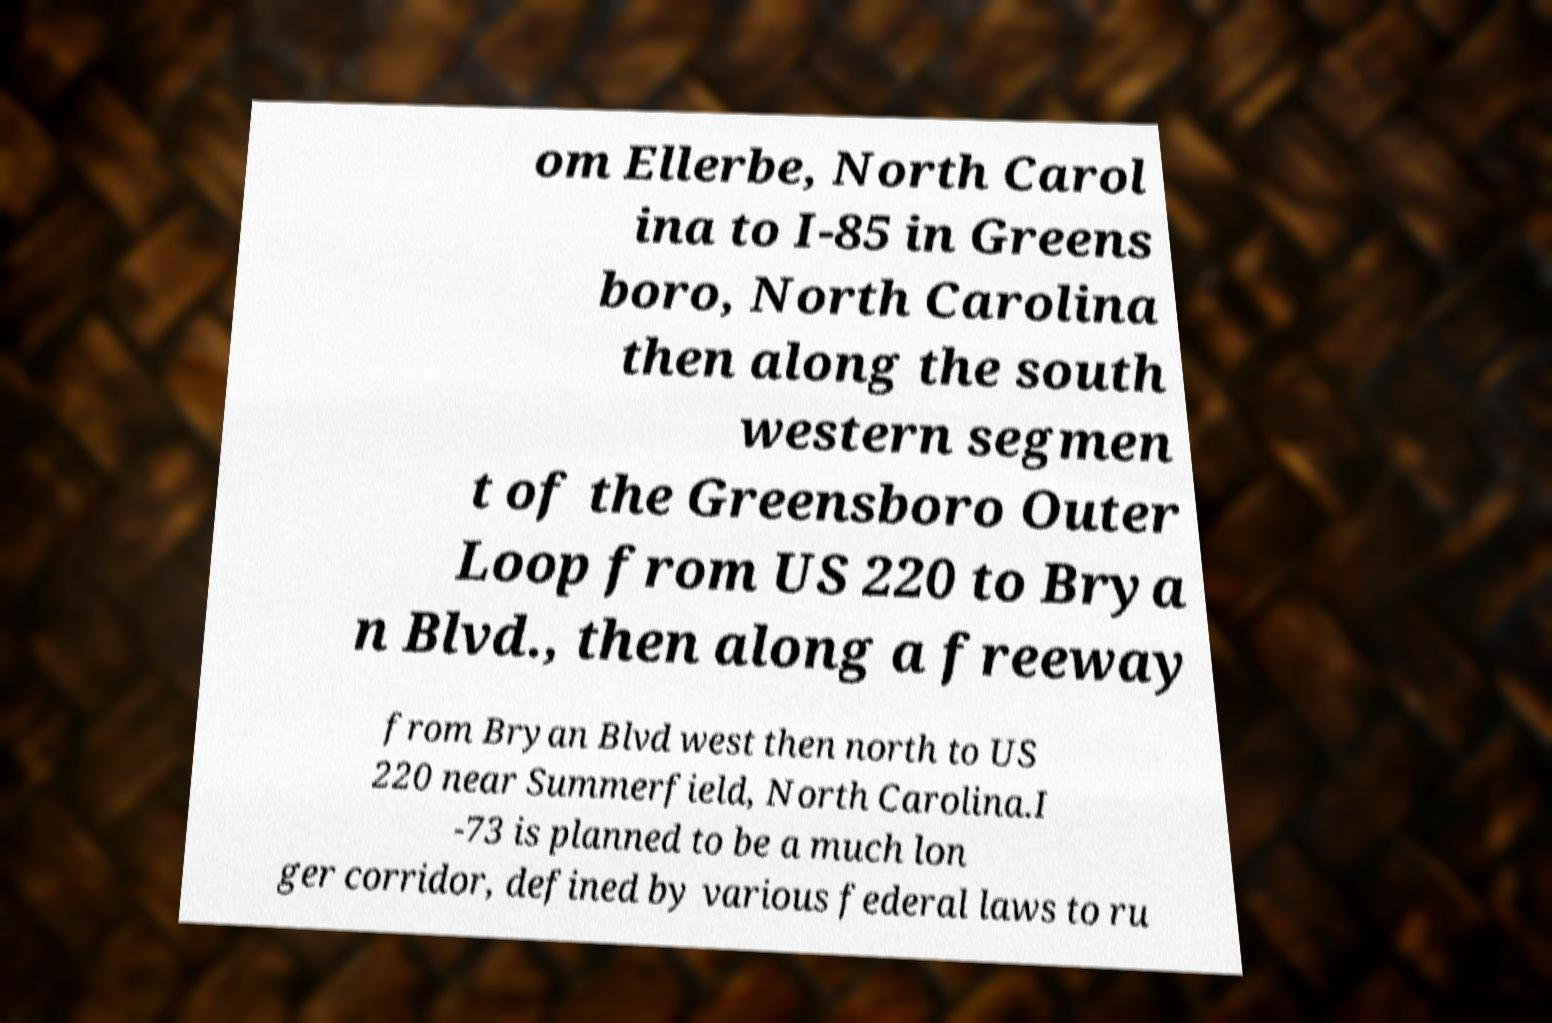Can you read and provide the text displayed in the image?This photo seems to have some interesting text. Can you extract and type it out for me? om Ellerbe, North Carol ina to I-85 in Greens boro, North Carolina then along the south western segmen t of the Greensboro Outer Loop from US 220 to Brya n Blvd., then along a freeway from Bryan Blvd west then north to US 220 near Summerfield, North Carolina.I -73 is planned to be a much lon ger corridor, defined by various federal laws to ru 